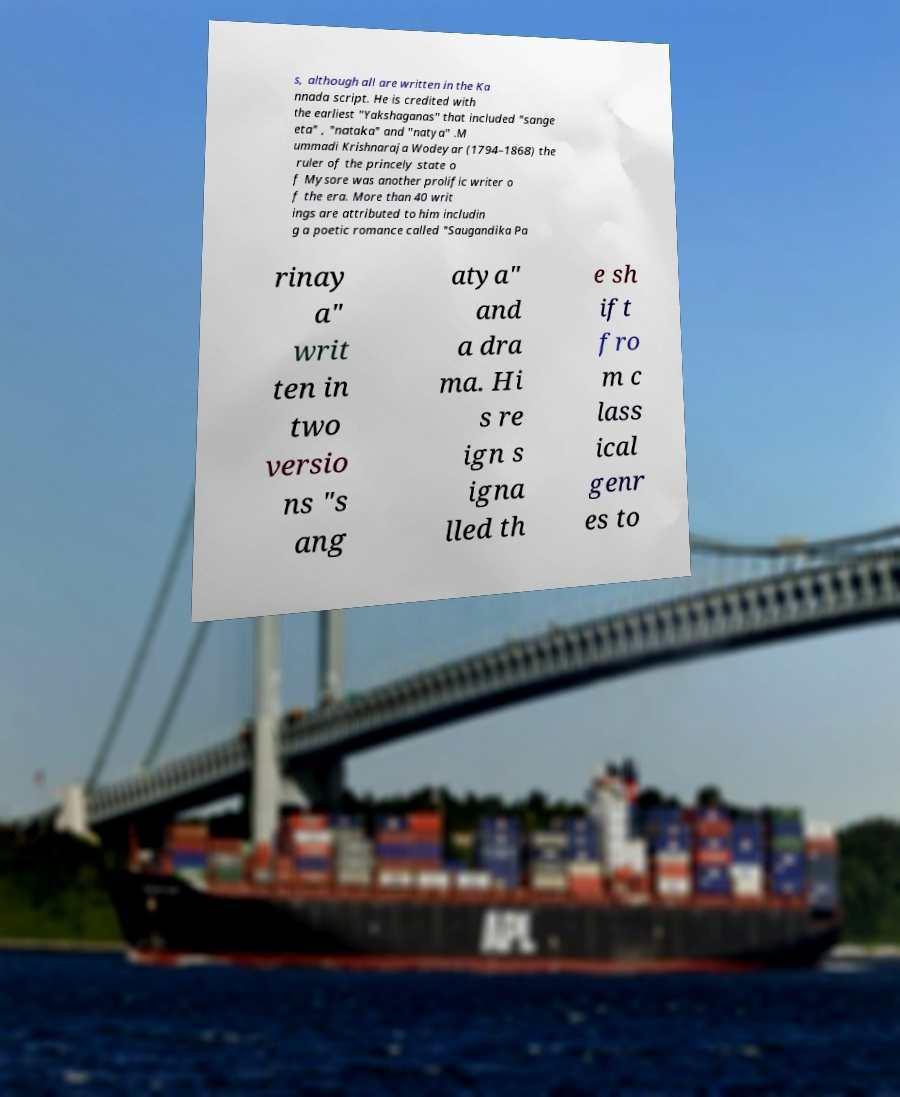Please read and relay the text visible in this image. What does it say? s, although all are written in the Ka nnada script. He is credited with the earliest "Yakshaganas" that included "sange eta" , "nataka" and "natya" .M ummadi Krishnaraja Wodeyar (1794–1868) the ruler of the princely state o f Mysore was another prolific writer o f the era. More than 40 writ ings are attributed to him includin g a poetic romance called "Saugandika Pa rinay a" writ ten in two versio ns "s ang atya" and a dra ma. Hi s re ign s igna lled th e sh ift fro m c lass ical genr es to 